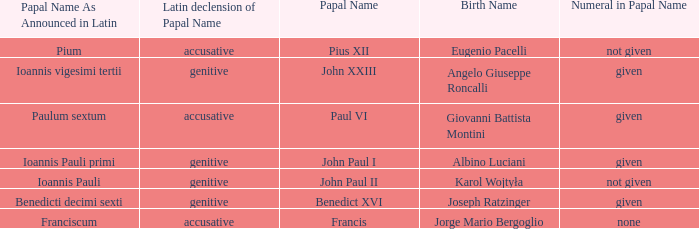What numeral is included for the pope with papal name in Latin of Ioannis Pauli? Not given. 